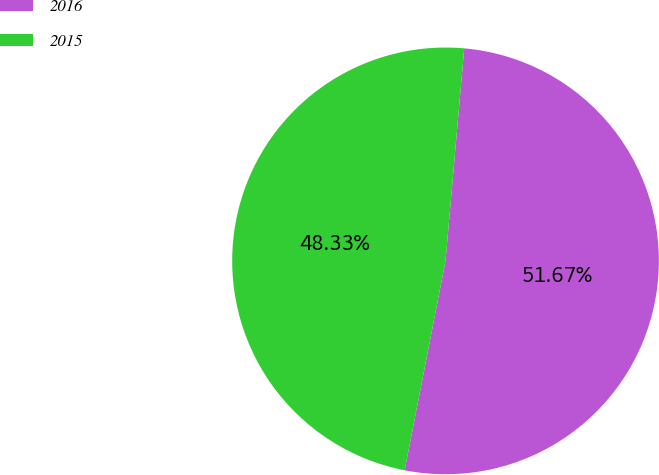Convert chart. <chart><loc_0><loc_0><loc_500><loc_500><pie_chart><fcel>2016<fcel>2015<nl><fcel>51.67%<fcel>48.33%<nl></chart> 